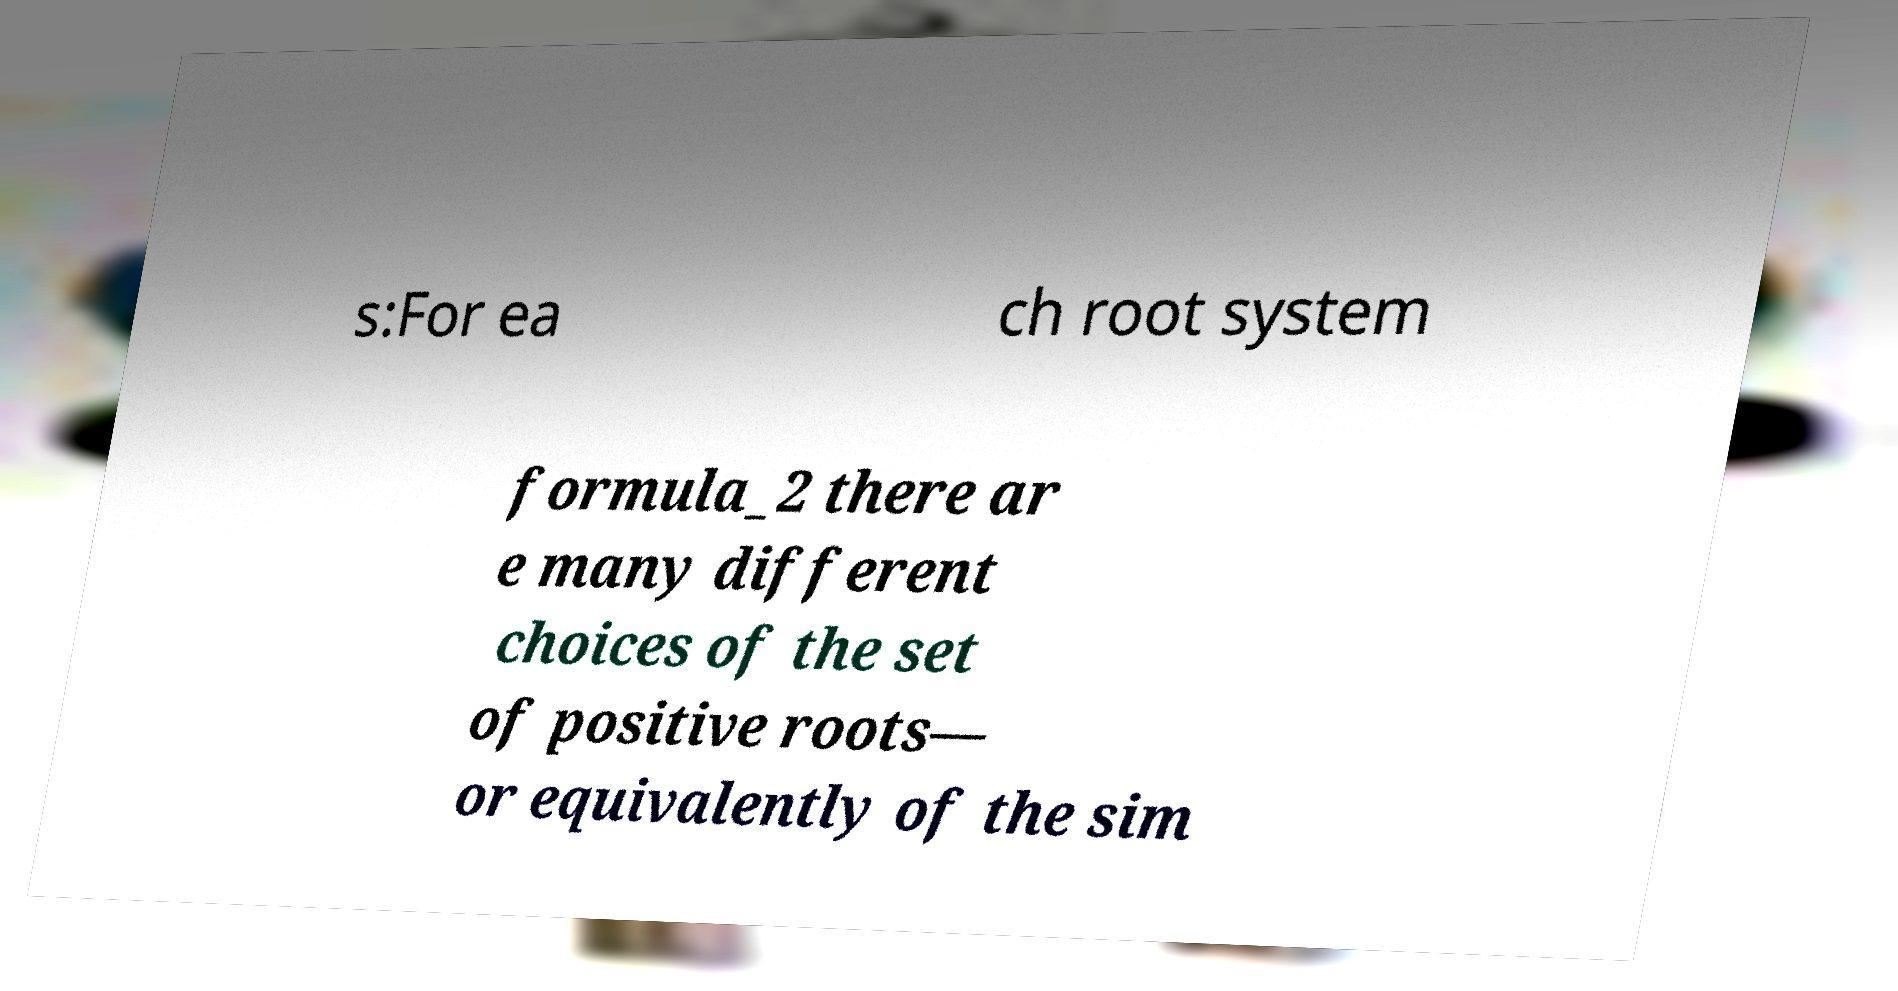I need the written content from this picture converted into text. Can you do that? s:For ea ch root system formula_2 there ar e many different choices of the set of positive roots— or equivalently of the sim 